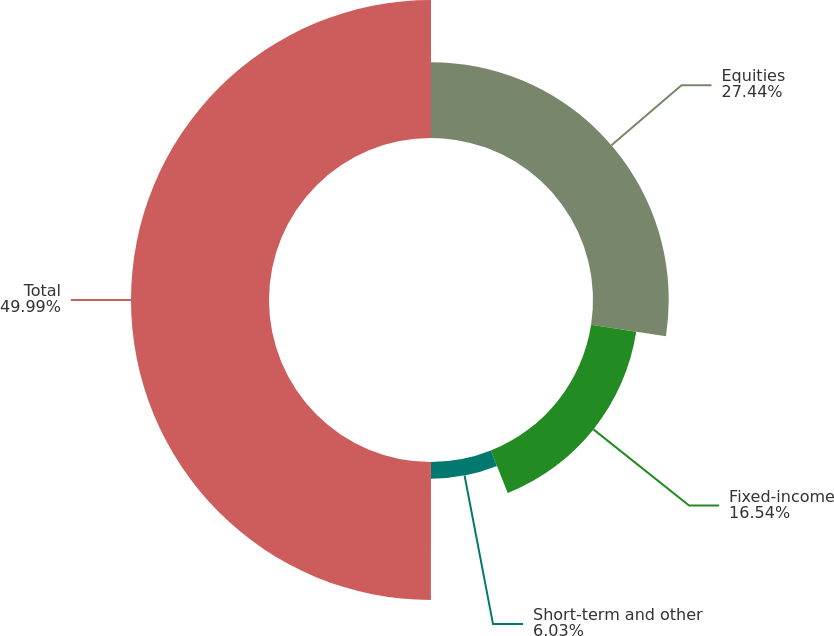<chart> <loc_0><loc_0><loc_500><loc_500><pie_chart><fcel>Equities<fcel>Fixed-income<fcel>Short-term and other<fcel>Total<nl><fcel>27.44%<fcel>16.54%<fcel>6.03%<fcel>50.0%<nl></chart> 